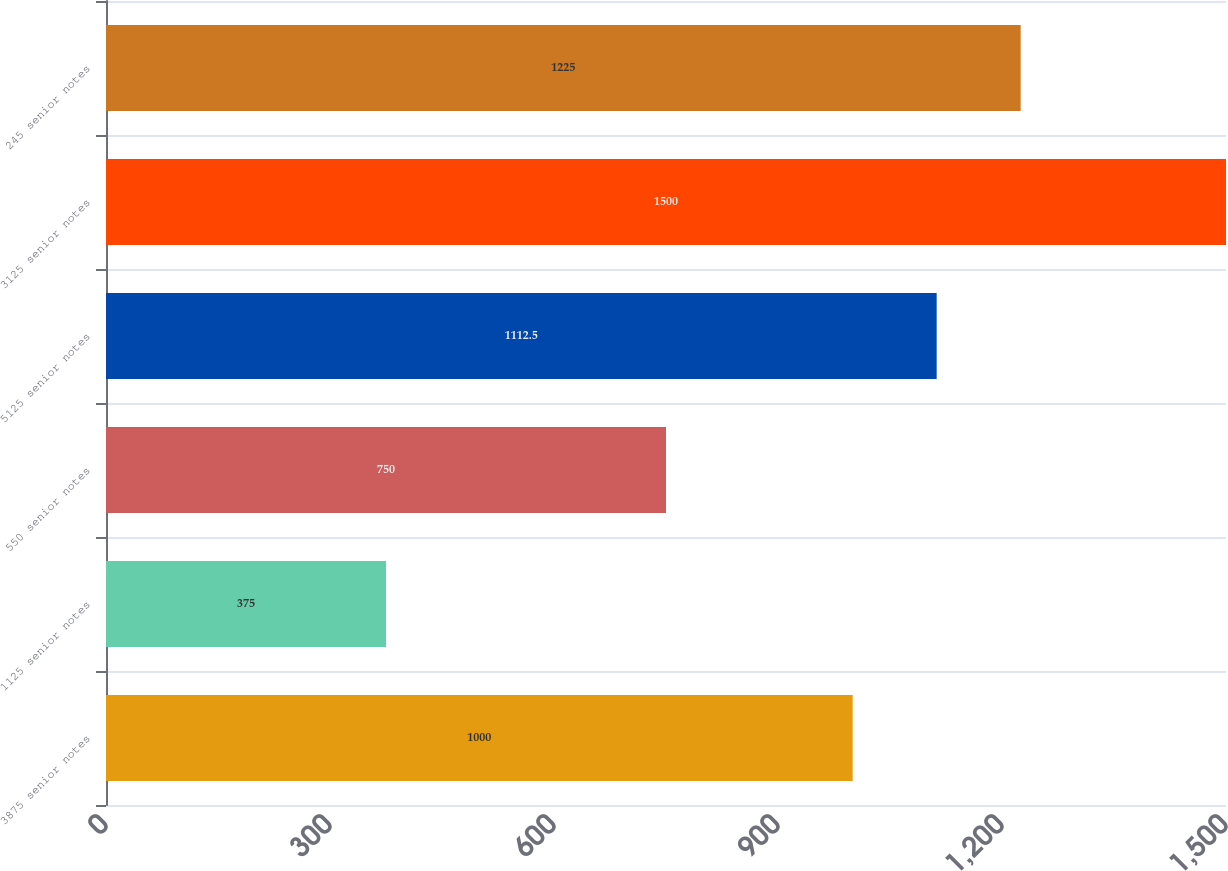<chart> <loc_0><loc_0><loc_500><loc_500><bar_chart><fcel>3875 senior notes<fcel>1125 senior notes<fcel>550 senior notes<fcel>5125 senior notes<fcel>3125 senior notes<fcel>245 senior notes<nl><fcel>1000<fcel>375<fcel>750<fcel>1112.5<fcel>1500<fcel>1225<nl></chart> 